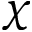Convert formula to latex. <formula><loc_0><loc_0><loc_500><loc_500>\chi</formula> 